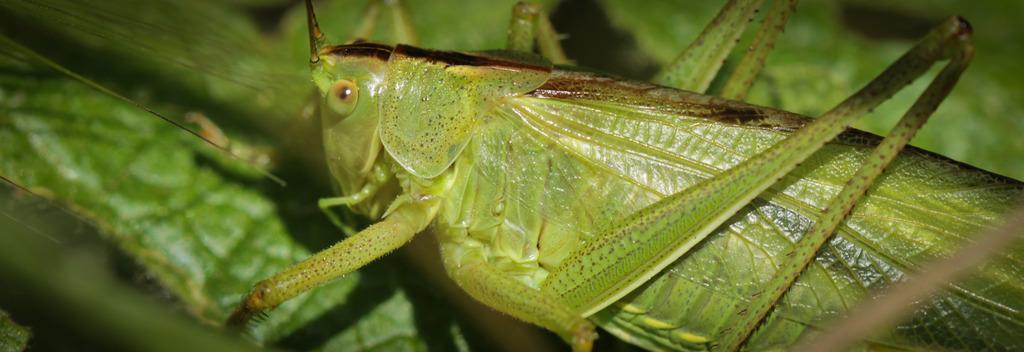Describe this image in one or two sentences. In this image we can see a grasshopper on leaf. Background it is blur. 